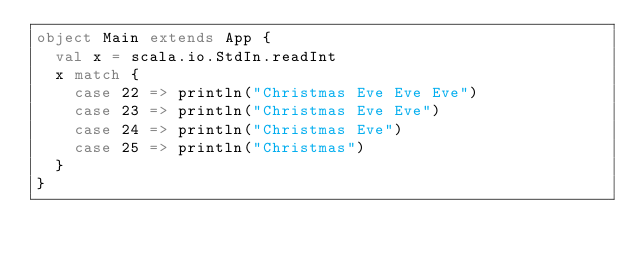Convert code to text. <code><loc_0><loc_0><loc_500><loc_500><_Scala_>object Main extends App {
	val x = scala.io.StdIn.readInt
	x match {
		case 22 => println("Christmas Eve Eve Eve")
		case 23 => println("Christmas Eve Eve")
		case 24 => println("Christmas Eve")
		case 25 => println("Christmas") 
	}
}</code> 